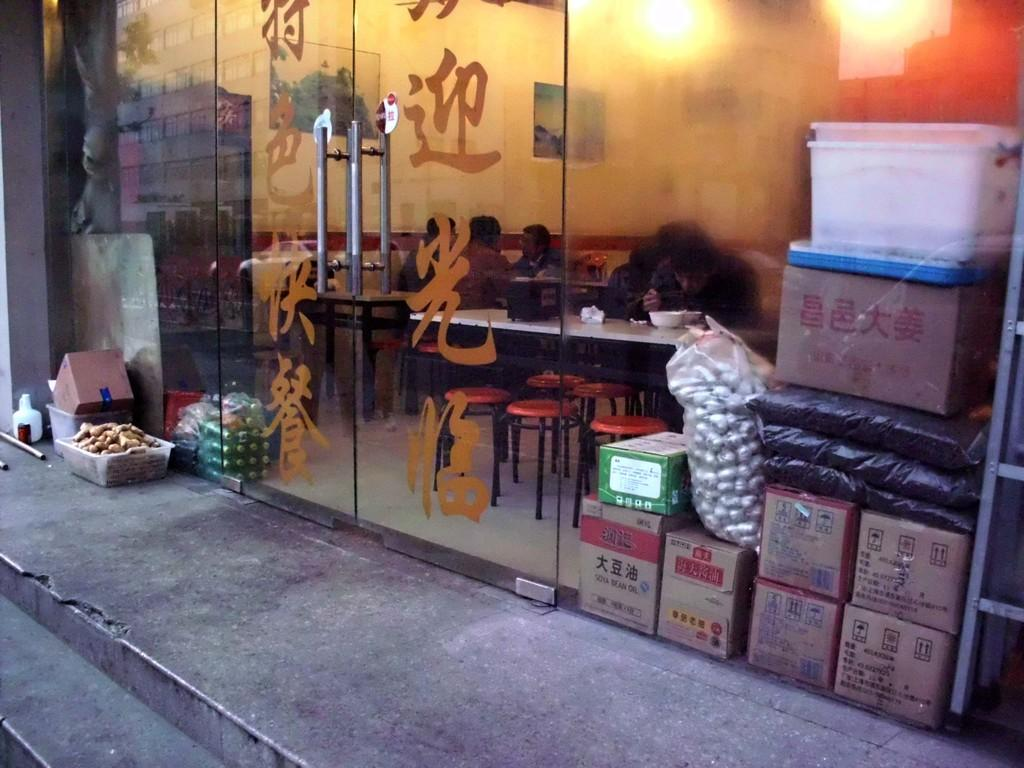What type of containers are visible in the image? There are cardboard boxes and bags in the image. Can you identify any specific items within the bags? Yes, there is a bag of garlic in the image. What can be seen in the background of the image? There are people sitting on chairs, a table, and a wall in the background of the image. What type of noise can be heard coming from the eye in the image? There is no eye present in the image, and therefore no noise can be heard from it. 